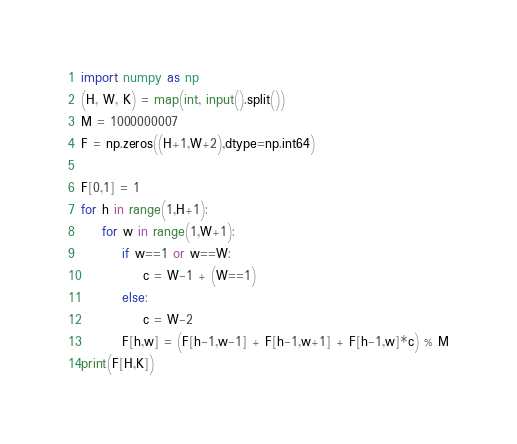<code> <loc_0><loc_0><loc_500><loc_500><_Python_>import numpy as np
(H, W, K) = map(int, input().split())
M = 1000000007
F = np.zeros((H+1,W+2),dtype=np.int64)

F[0,1] = 1
for h in range(1,H+1):
    for w in range(1,W+1):
        if w==1 or w==W:
            c = W-1 + (W==1)
        else:
            c = W-2
        F[h,w] = (F[h-1,w-1] + F[h-1,w+1] + F[h-1,w]*c) % M
print(F[H,K])</code> 